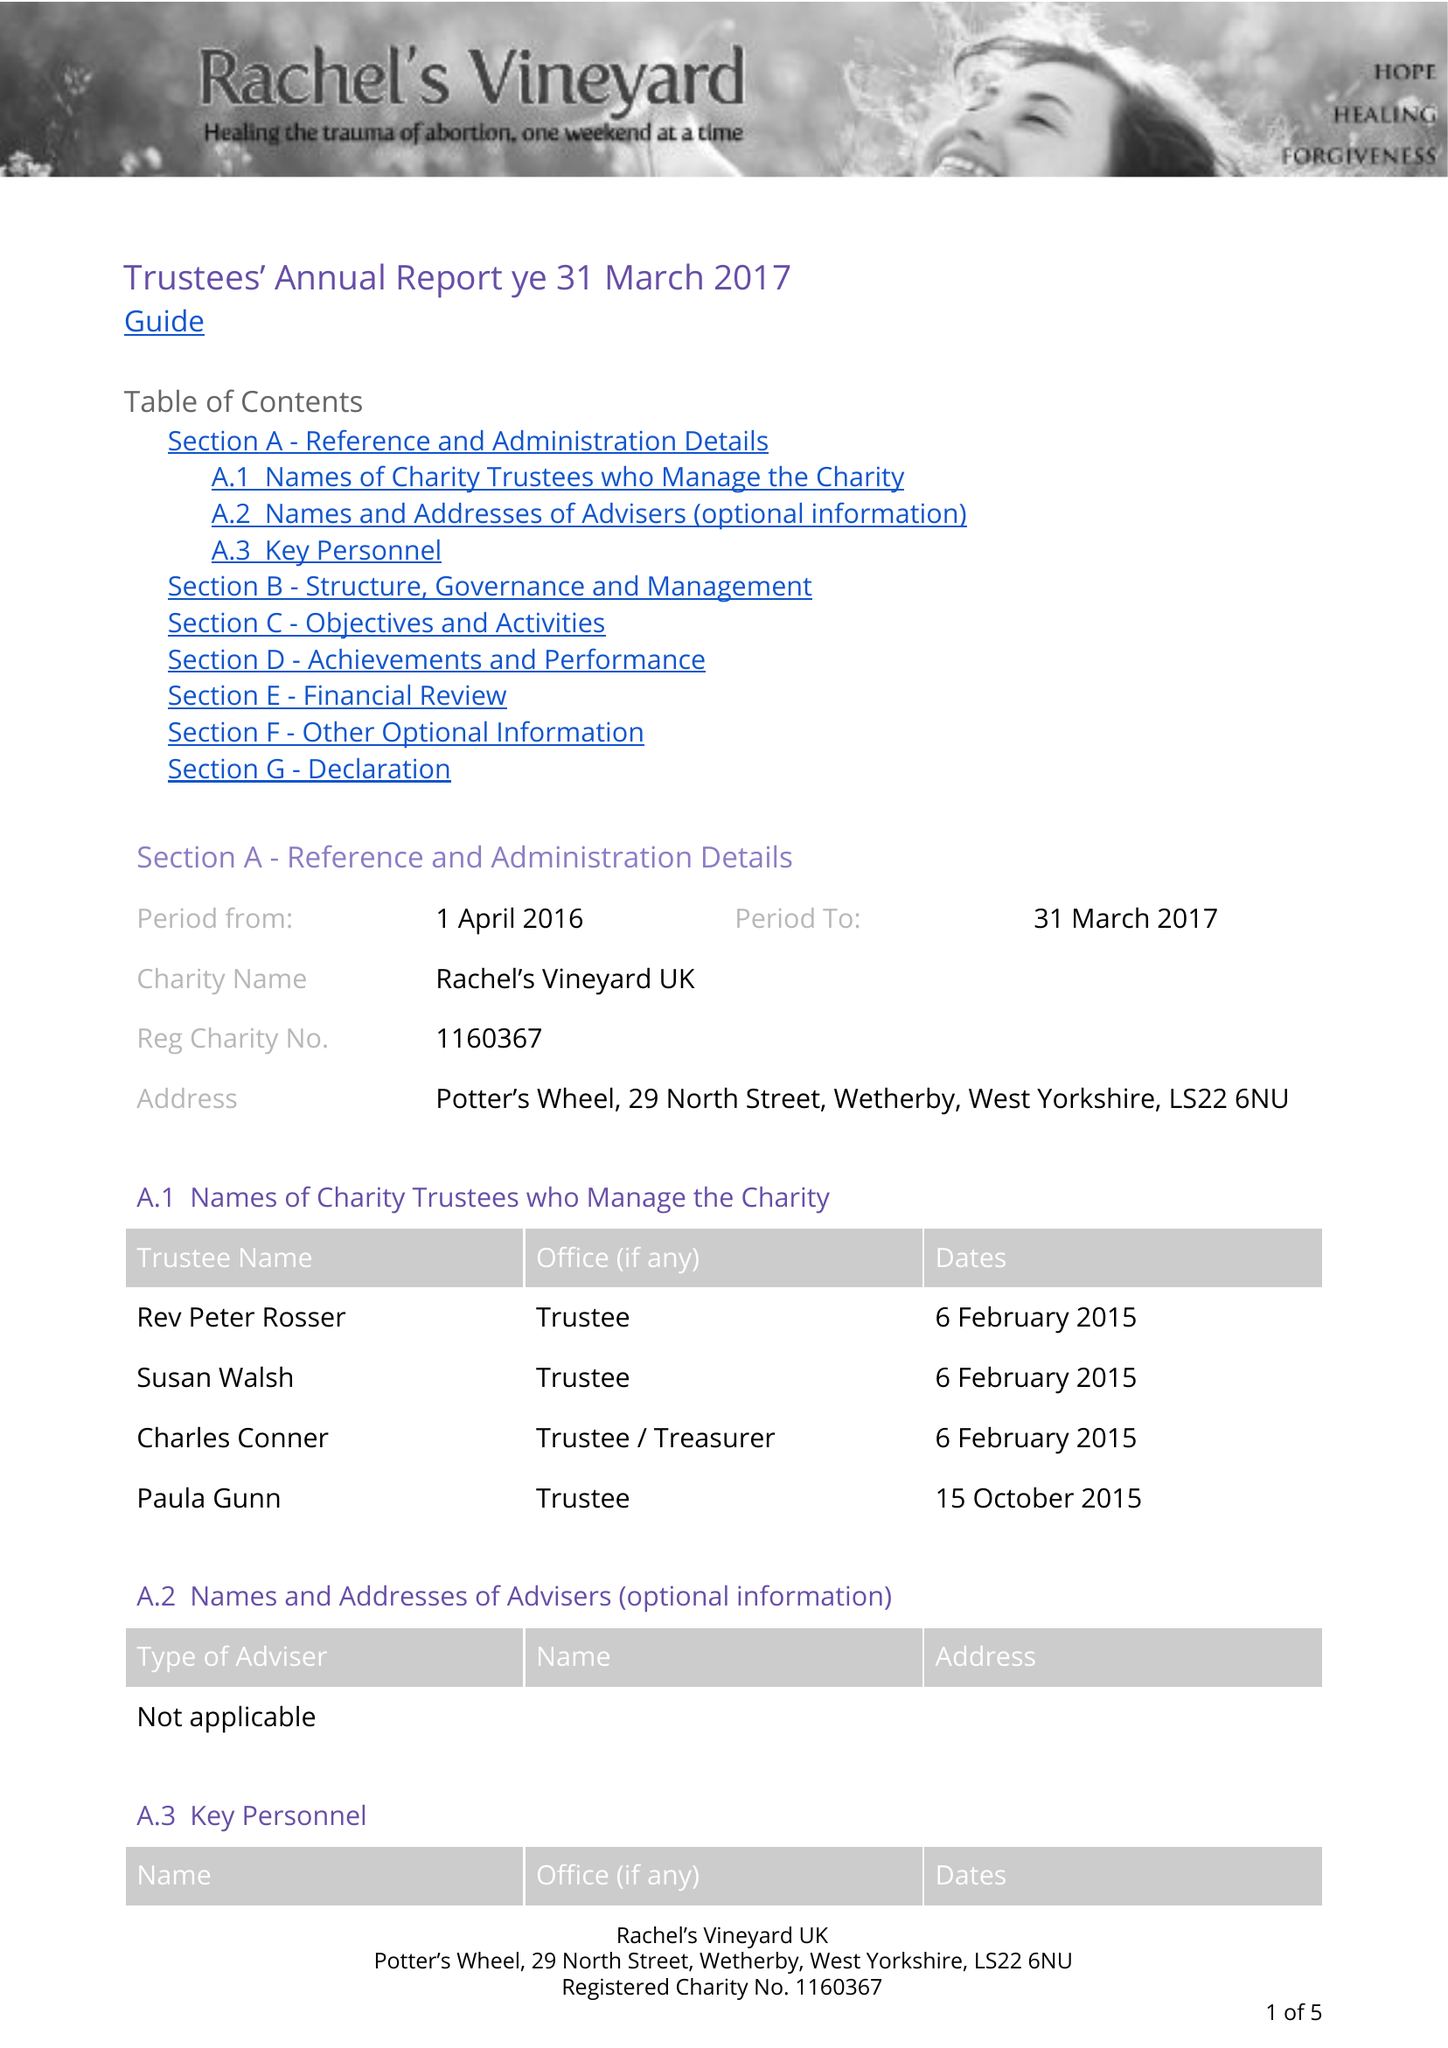What is the value for the charity_number?
Answer the question using a single word or phrase. 1160367 